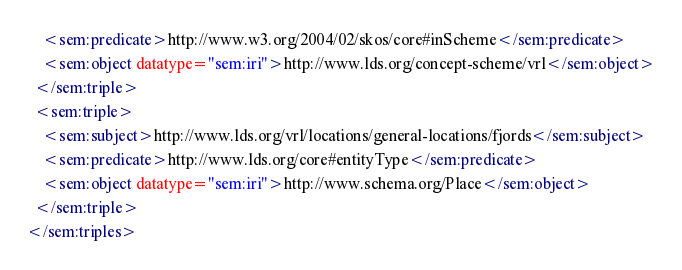Convert code to text. <code><loc_0><loc_0><loc_500><loc_500><_XML_>    <sem:predicate>http://www.w3.org/2004/02/skos/core#inScheme</sem:predicate>
    <sem:object datatype="sem:iri">http://www.lds.org/concept-scheme/vrl</sem:object>
  </sem:triple>
  <sem:triple>
    <sem:subject>http://www.lds.org/vrl/locations/general-locations/fjords</sem:subject>
    <sem:predicate>http://www.lds.org/core#entityType</sem:predicate>
    <sem:object datatype="sem:iri">http://www.schema.org/Place</sem:object>
  </sem:triple>
</sem:triples>
</code> 